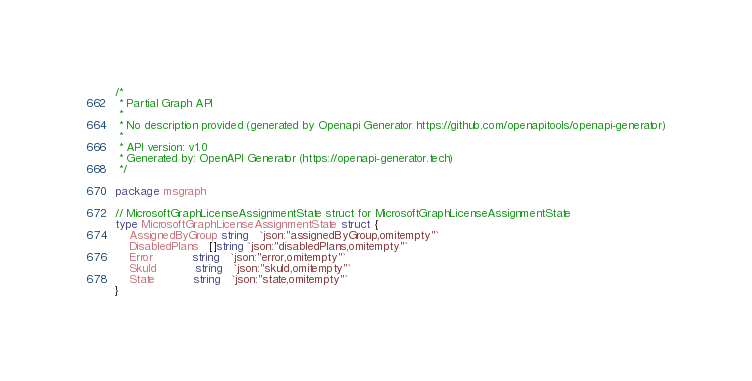<code> <loc_0><loc_0><loc_500><loc_500><_Go_>/*
 * Partial Graph API
 *
 * No description provided (generated by Openapi Generator https://github.com/openapitools/openapi-generator)
 *
 * API version: v1.0
 * Generated by: OpenAPI Generator (https://openapi-generator.tech)
 */

package msgraph

// MicrosoftGraphLicenseAssignmentState struct for MicrosoftGraphLicenseAssignmentState
type MicrosoftGraphLicenseAssignmentState struct {
	AssignedByGroup string   `json:"assignedByGroup,omitempty"`
	DisabledPlans   []string `json:"disabledPlans,omitempty"`
	Error           string   `json:"error,omitempty"`
	SkuId           string   `json:"skuId,omitempty"`
	State           string   `json:"state,omitempty"`
}
</code> 